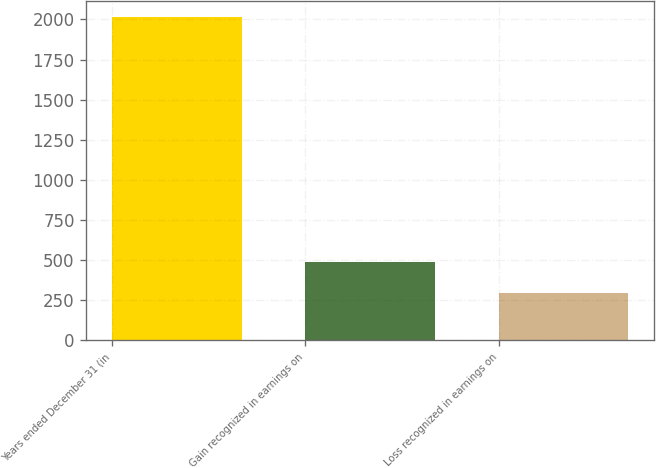Convert chart. <chart><loc_0><loc_0><loc_500><loc_500><bar_chart><fcel>Years ended December 31 (in<fcel>Gain recognized in earnings on<fcel>Loss recognized in earnings on<nl><fcel>2013<fcel>484.2<fcel>293.1<nl></chart> 